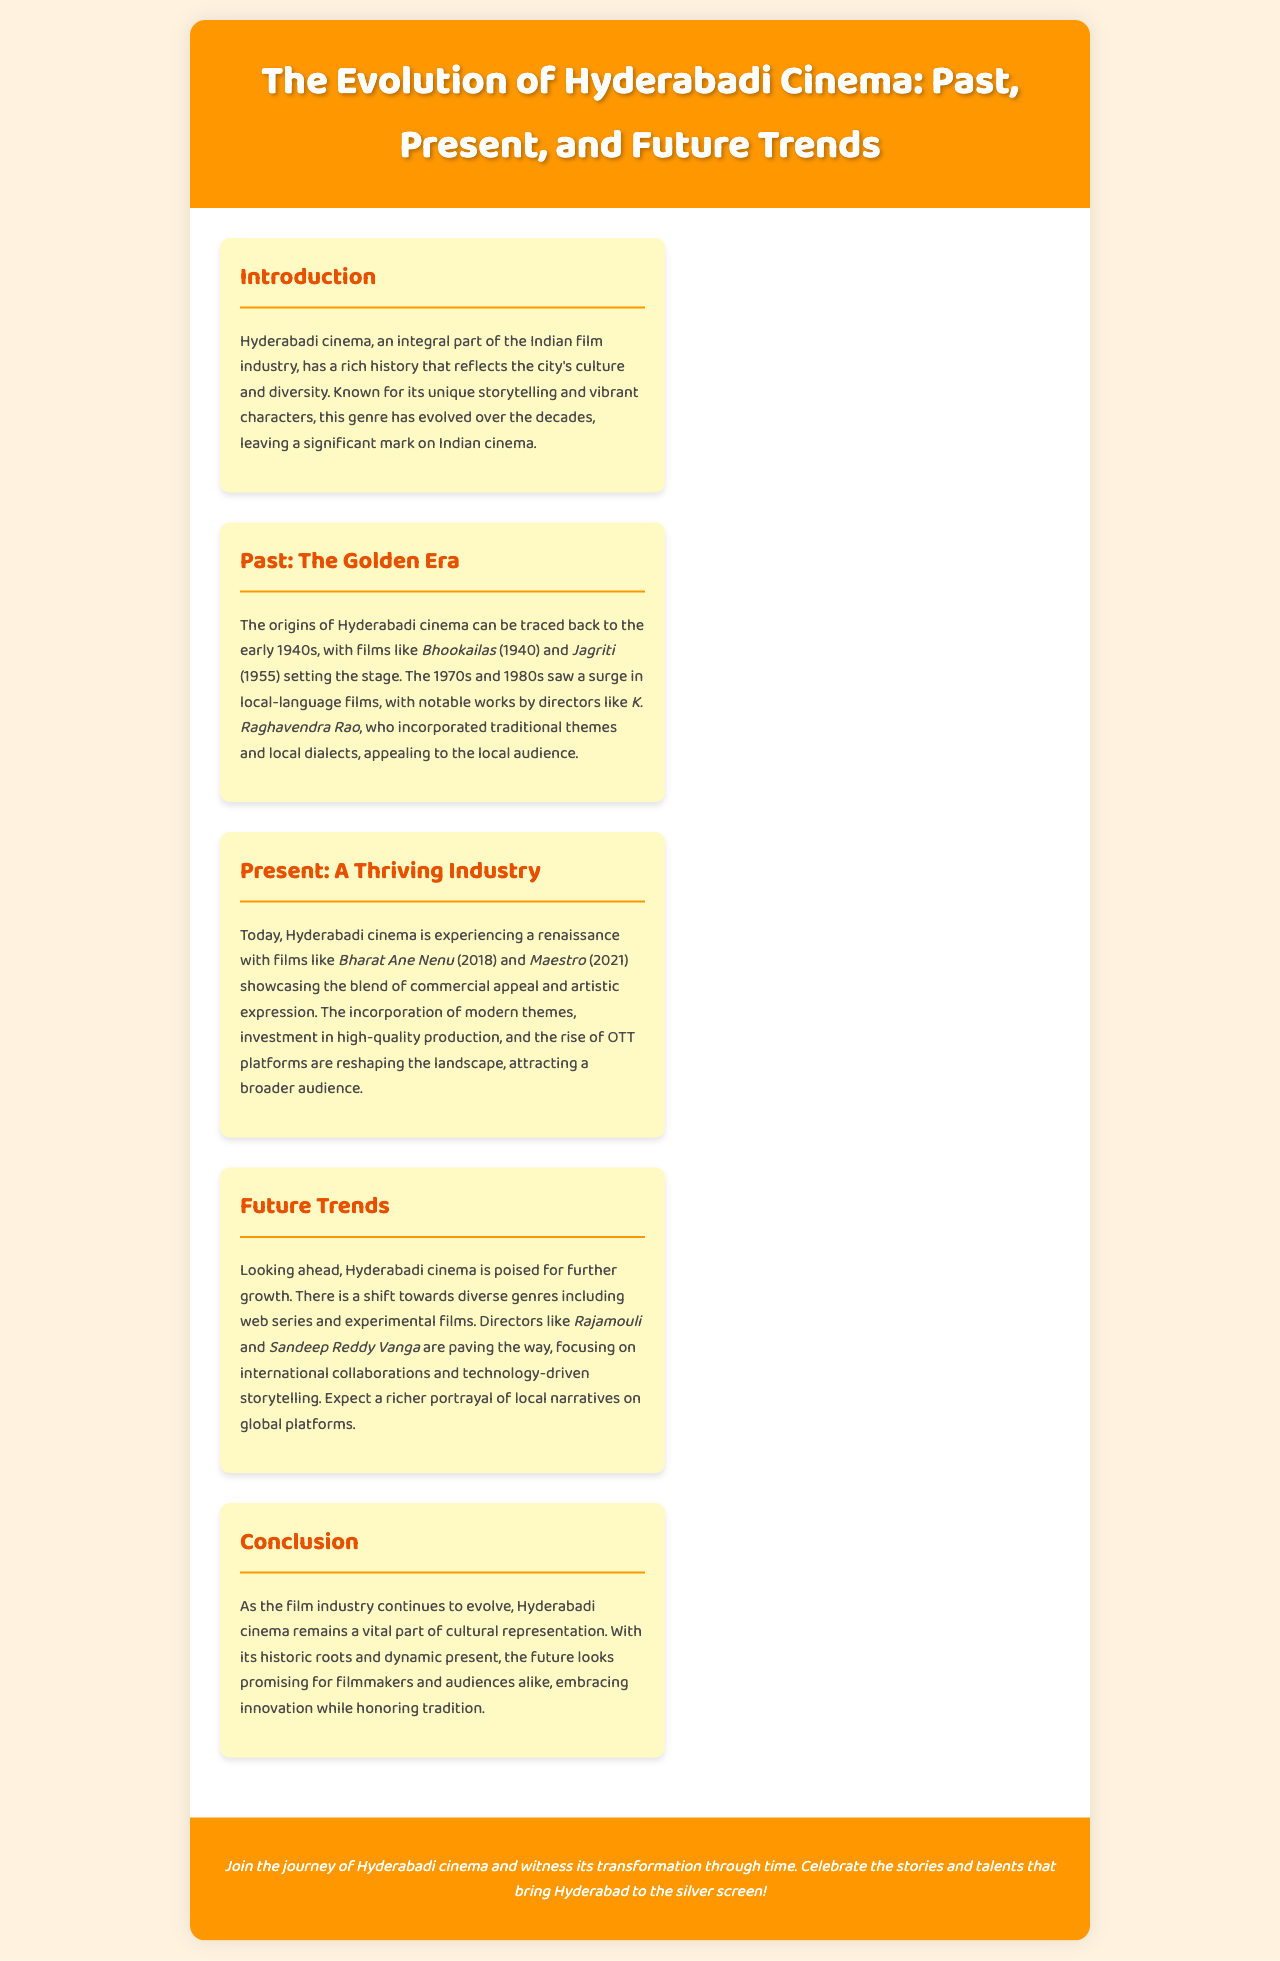what year did the origins of Hyderabadi cinema start? The document states that the origins of Hyderabadi cinema can be traced back to the early 1940s.
Answer: 1940s which director is mentioned for the notable works in the golden era? The document specifies K. Raghavendra Rao as a notable director during the golden era of Hyderabadi cinema.
Answer: K. Raghavendra Rao name one film that showcases the present thriving industry of Hyderabadi cinema. The document lists Bharat Ane Nenu as an example of a film from the present thriving industry.
Answer: Bharat Ane Nenu what type of films are Hyderabadi cinema directors focusing on for the future? The document mentions that directors are shifting towards web series and experimental films for the future.
Answer: web series and experimental films how does the brochure describe the future of Hyderabadi cinema? The document describes the future of Hyderabadi cinema as promising and poised for further growth.
Answer: promising what color is the footer of the brochure? The document indicates that the footer has a background color of orange (#FF9800).
Answer: orange who are two directors paving the way for future trends in Hyderabadi cinema? The document names Rajamouli and Sandeep Reddy Vanga as directors paving the way for future trends.
Answer: Rajamouli and Sandeep Reddy Vanga what significant change is highlighted in the present section of the brochure? The present section highlights the incorporation of modern themes and investment in high-quality production as significant changes.
Answer: incorporation of modern themes what is the main focus of the introduction section in the brochure? The introduction section focuses on Hyderabadi cinema's rich history and its reflection of the city’s culture and diversity.
Answer: rich history and culture 